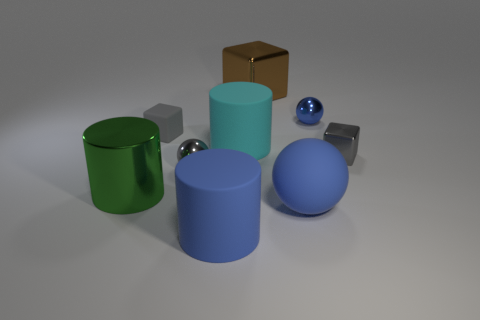What color is the tiny metallic sphere right of the large blue sphere? The tiny metallic sphere situated to the right of the large blue sphere appears to be silver, reflecting the environment with its shiny surface. 